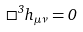<formula> <loc_0><loc_0><loc_500><loc_500>\Box ^ { 3 } h _ { \mu \nu } = 0</formula> 